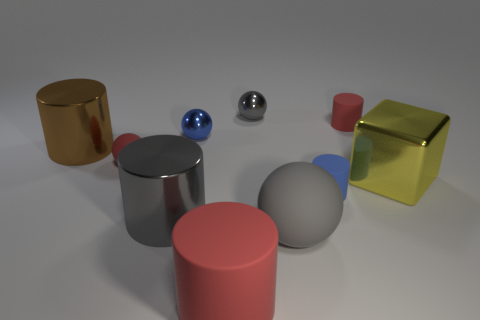Subtract 1 spheres. How many spheres are left? 3 Subtract all small balls. How many balls are left? 1 Subtract all brown cylinders. How many cylinders are left? 4 Subtract all cyan cylinders. Subtract all red cubes. How many cylinders are left? 5 Subtract all cubes. How many objects are left? 9 Subtract all large green rubber cubes. Subtract all gray cylinders. How many objects are left? 9 Add 3 gray balls. How many gray balls are left? 5 Add 1 yellow cylinders. How many yellow cylinders exist? 1 Subtract 1 yellow blocks. How many objects are left? 9 